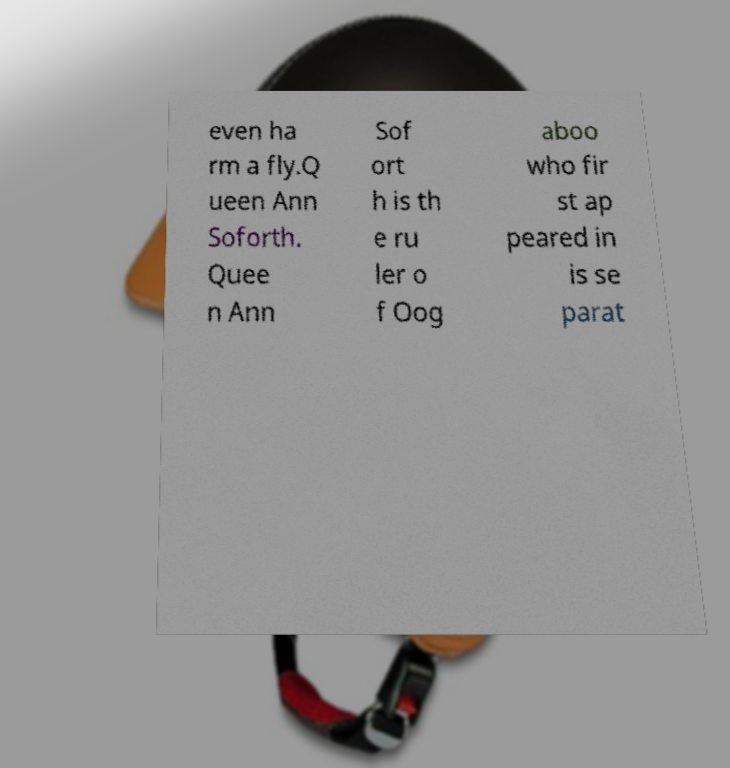Could you extract and type out the text from this image? even ha rm a fly.Q ueen Ann Soforth. Quee n Ann Sof ort h is th e ru ler o f Oog aboo who fir st ap peared in is se parat 